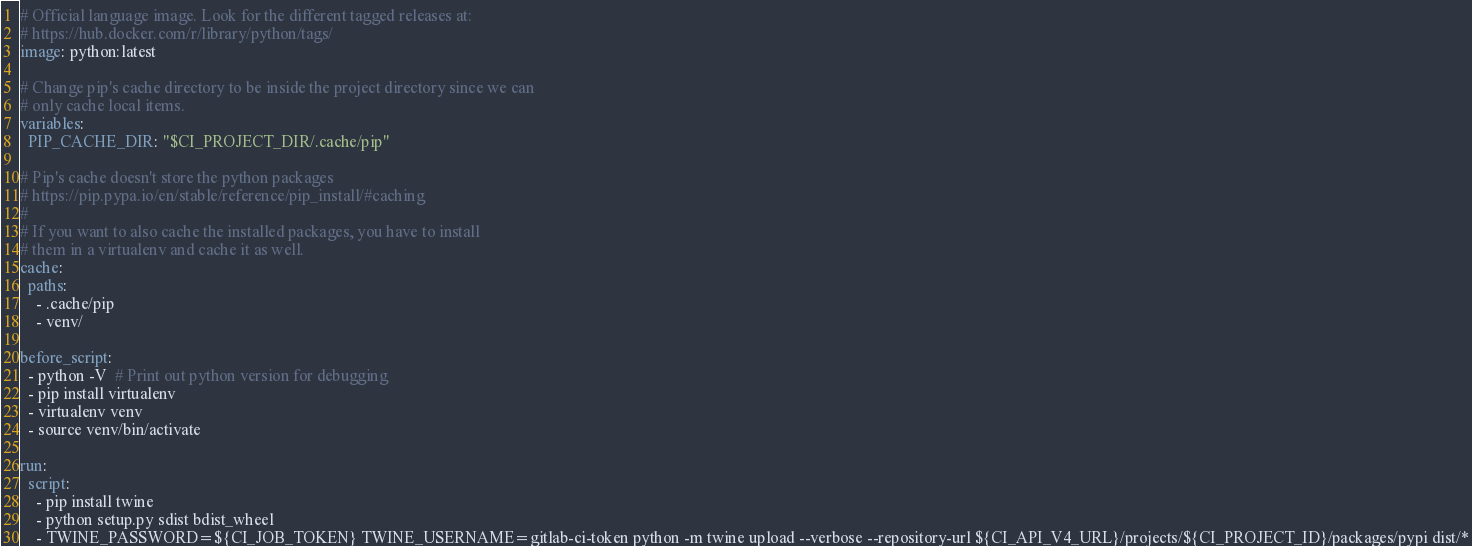<code> <loc_0><loc_0><loc_500><loc_500><_YAML_># Official language image. Look for the different tagged releases at:
# https://hub.docker.com/r/library/python/tags/
image: python:latest

# Change pip's cache directory to be inside the project directory since we can
# only cache local items.
variables:
  PIP_CACHE_DIR: "$CI_PROJECT_DIR/.cache/pip"

# Pip's cache doesn't store the python packages
# https://pip.pypa.io/en/stable/reference/pip_install/#caching
#
# If you want to also cache the installed packages, you have to install
# them in a virtualenv and cache it as well.
cache:
  paths:
    - .cache/pip
    - venv/

before_script:
  - python -V  # Print out python version for debugging
  - pip install virtualenv
  - virtualenv venv
  - source venv/bin/activate

run:
  script:
    - pip install twine
    - python setup.py sdist bdist_wheel
    - TWINE_PASSWORD=${CI_JOB_TOKEN} TWINE_USERNAME=gitlab-ci-token python -m twine upload --verbose --repository-url ${CI_API_V4_URL}/projects/${CI_PROJECT_ID}/packages/pypi dist/*

</code> 